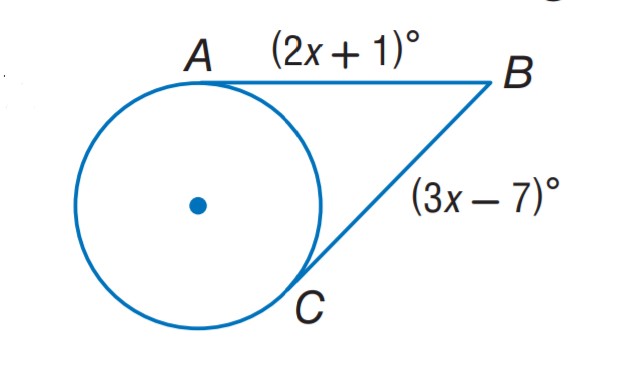Answer the mathemtical geometry problem and directly provide the correct option letter.
Question: The segment is tangent to the circle. Find x.
Choices: A: 6 B: 7 C: 8 D: 9 C 